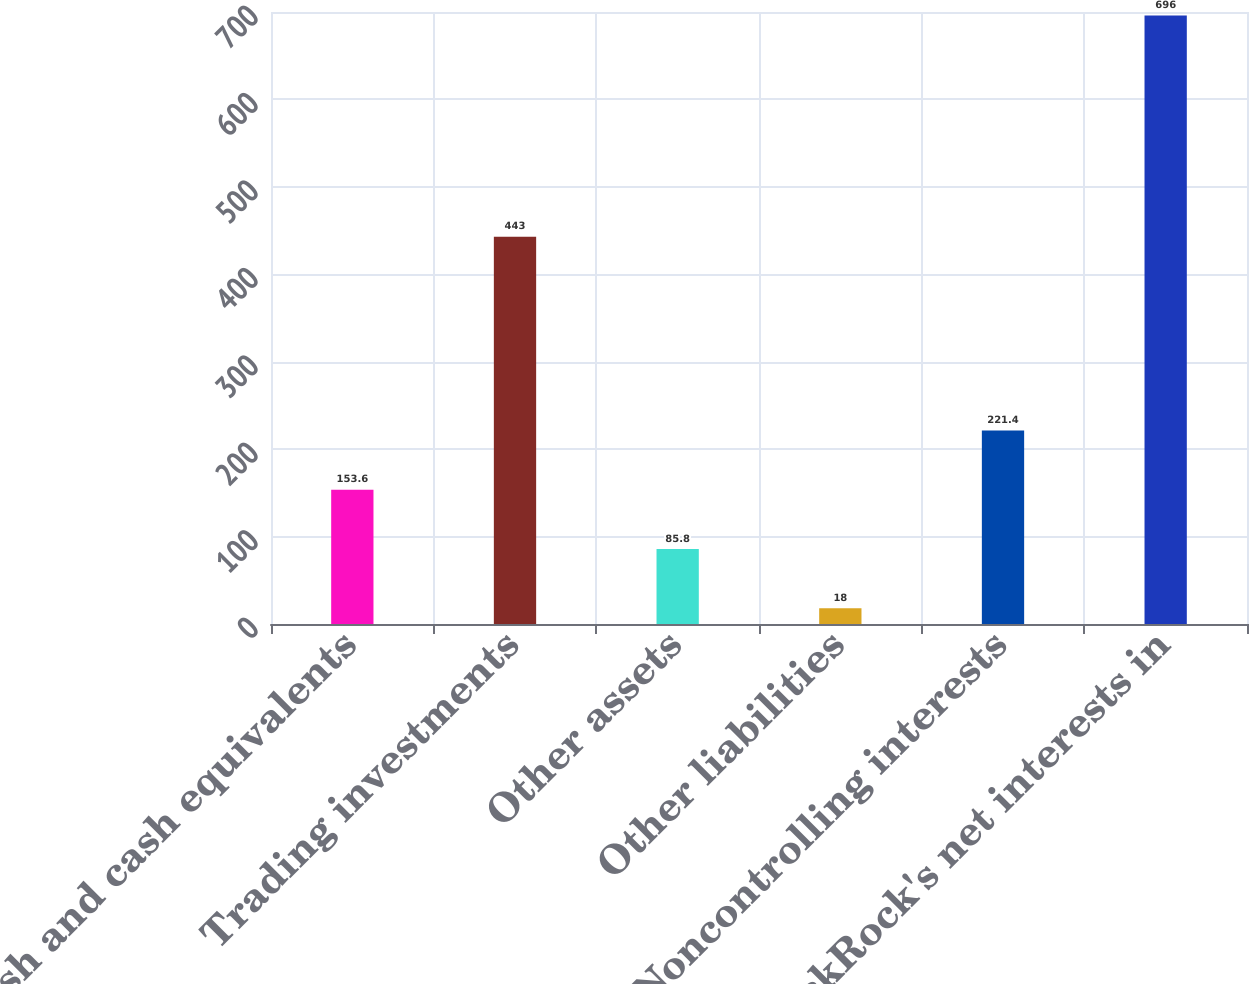Convert chart. <chart><loc_0><loc_0><loc_500><loc_500><bar_chart><fcel>Cash and cash equivalents<fcel>Trading investments<fcel>Other assets<fcel>Other liabilities<fcel>Noncontrolling interests<fcel>BlackRock's net interests in<nl><fcel>153.6<fcel>443<fcel>85.8<fcel>18<fcel>221.4<fcel>696<nl></chart> 